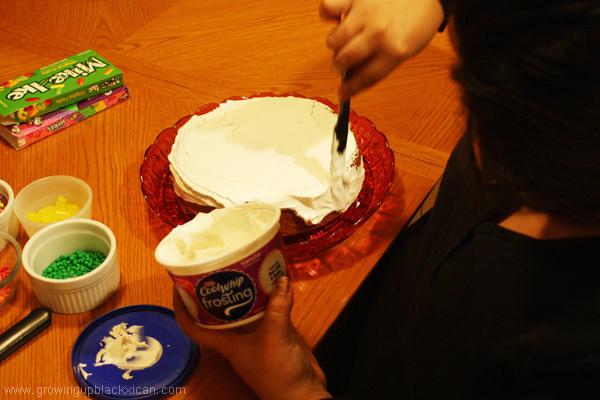What kind of cake is this?
Give a very brief answer. Red velvet. Why are there shadows cast?
Be succinct. Table. Are there bananas in the picture?
Keep it brief. No. What brand of candy is in the green box?
Answer briefly. Mike and ike. Is the frosting chocolate?
Write a very short answer. No. 